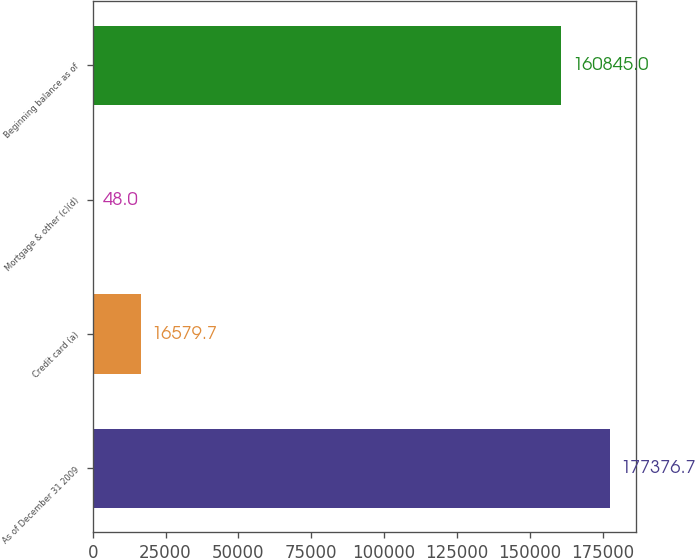Convert chart to OTSL. <chart><loc_0><loc_0><loc_500><loc_500><bar_chart><fcel>As of December 31 2009<fcel>Credit card (a)<fcel>Mortgage & other (c)(d)<fcel>Beginning balance as of<nl><fcel>177377<fcel>16579.7<fcel>48<fcel>160845<nl></chart> 